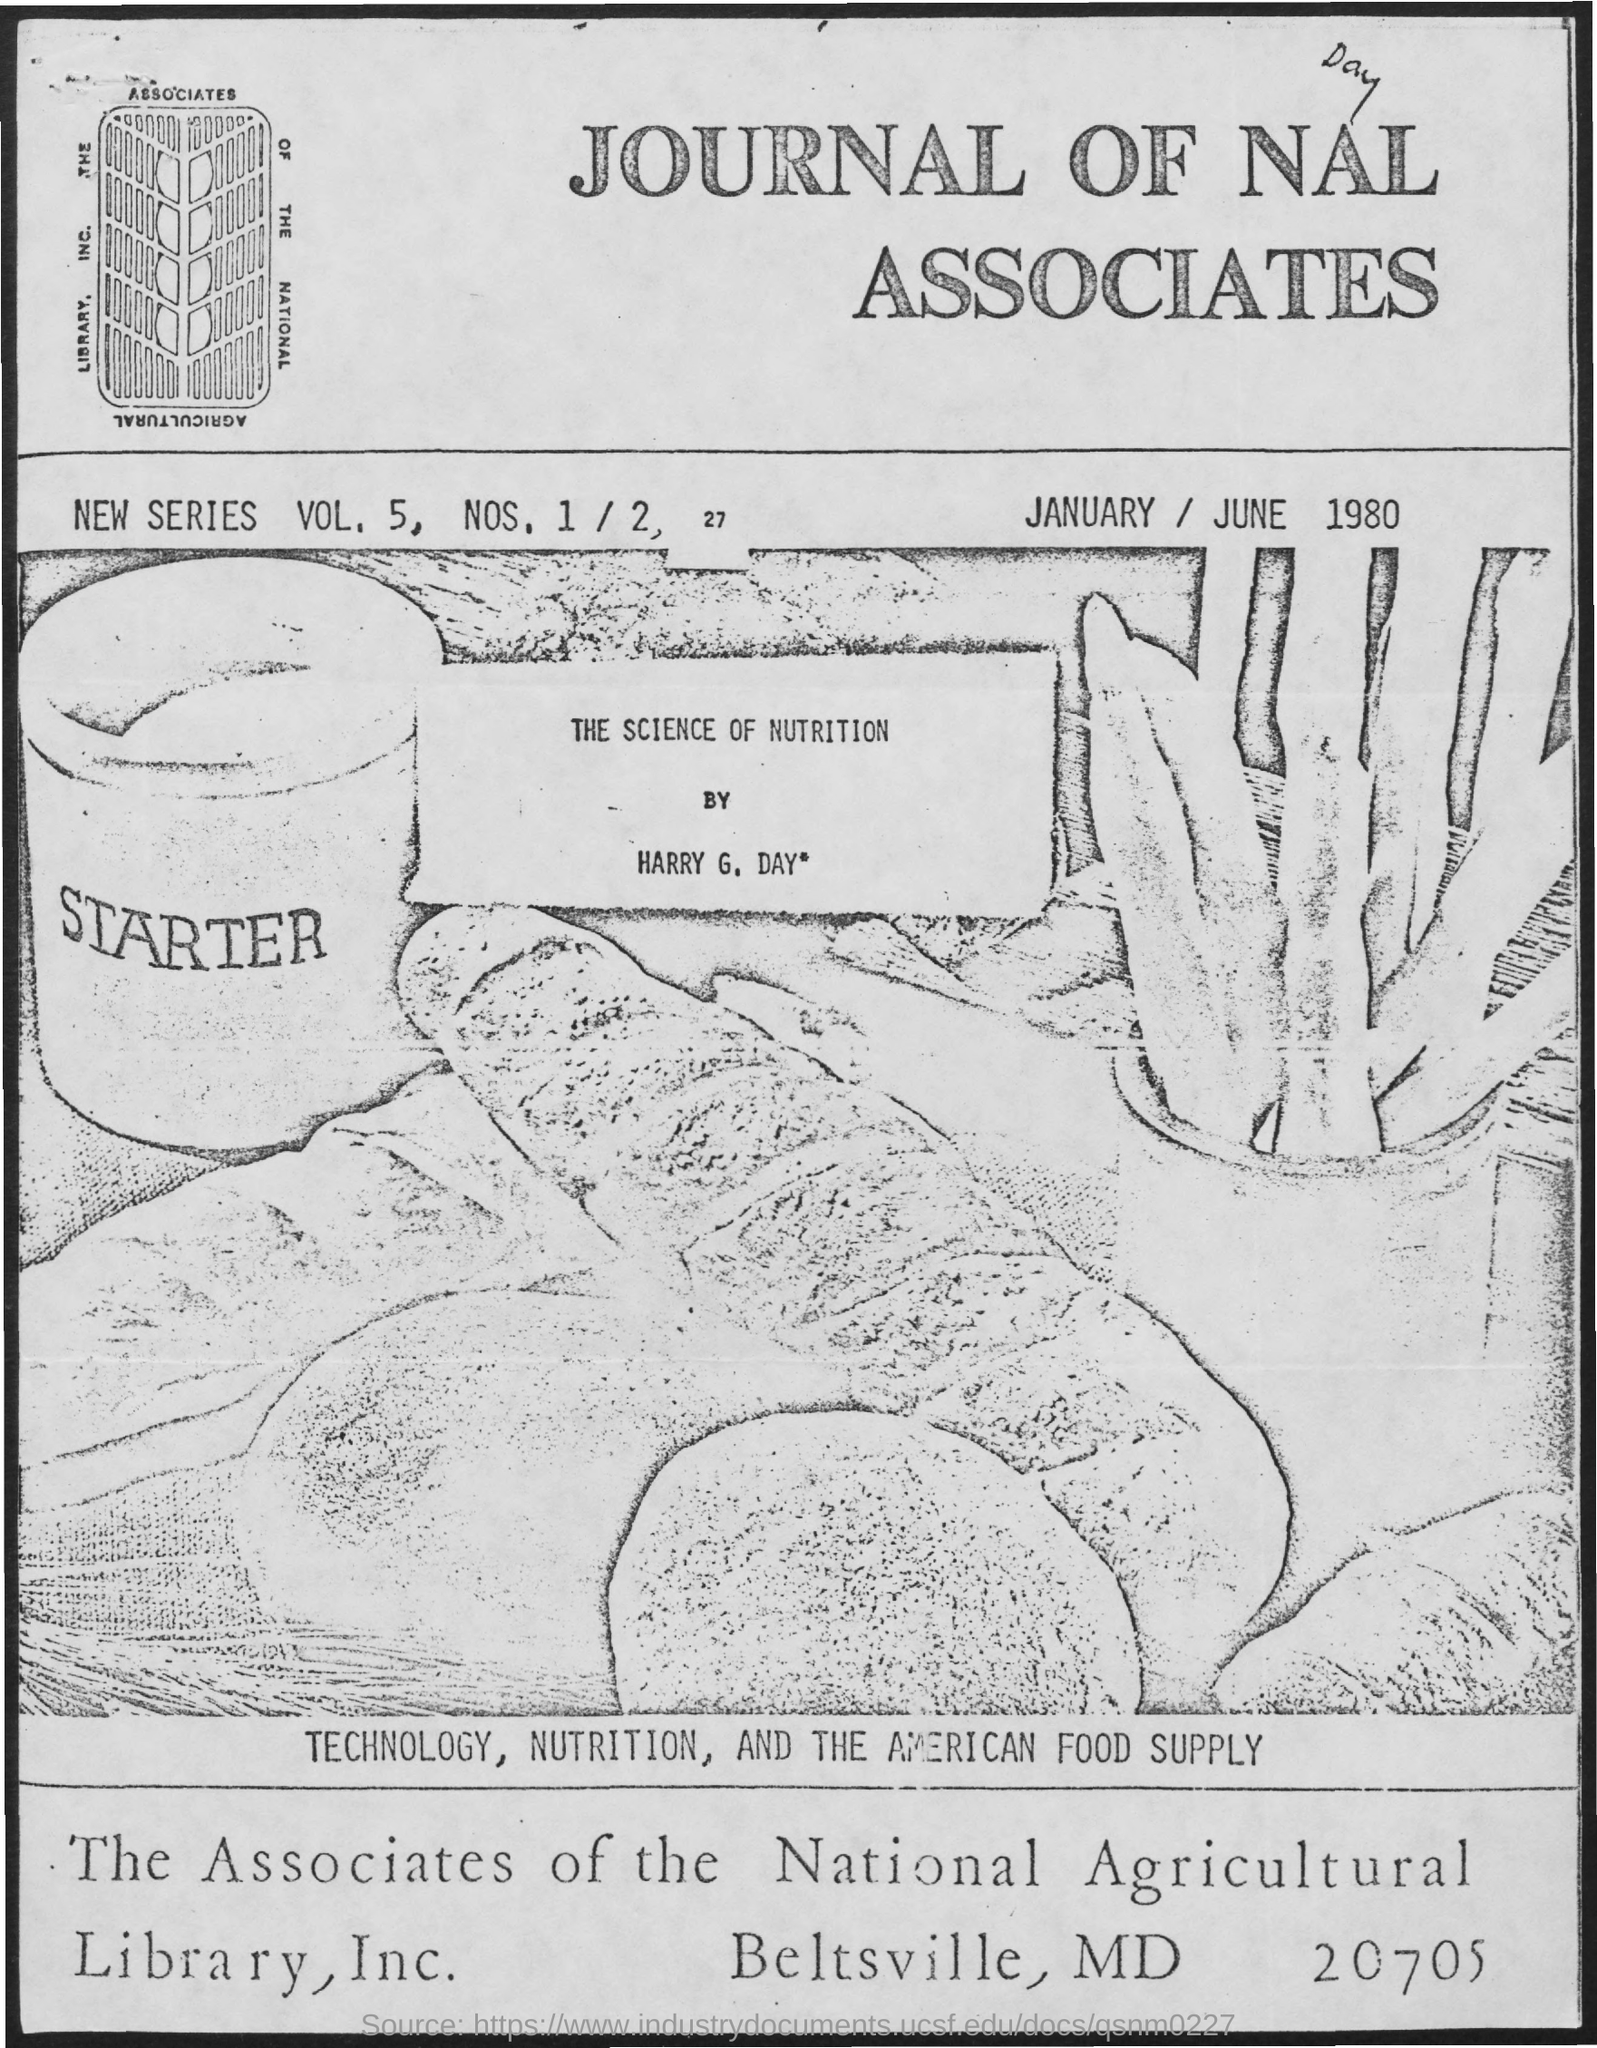What is the vol. no. mentioned ?
Give a very brief answer. 5. What is the name of the library mentioned ?
Provide a short and direct response. The associates of the national agricultural library, inc. 